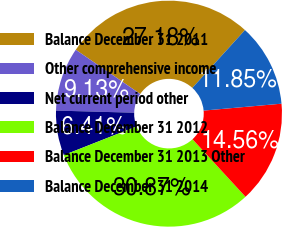<chart> <loc_0><loc_0><loc_500><loc_500><pie_chart><fcel>Balance December 31 2011<fcel>Other comprehensive income<fcel>Net current period other<fcel>Balance December 31 2012<fcel>Balance December 31 2013 Other<fcel>Balance December 31 2014<nl><fcel>27.18%<fcel>9.13%<fcel>6.41%<fcel>30.87%<fcel>14.56%<fcel>11.85%<nl></chart> 